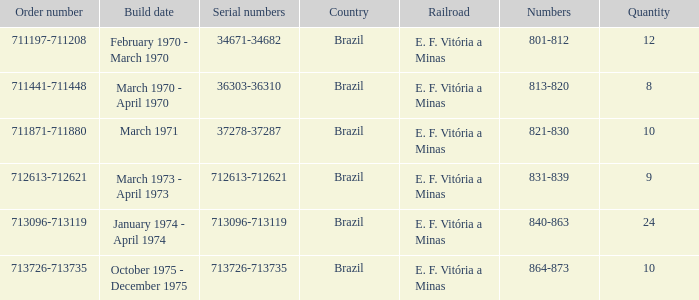The sequence numbers 713096-713119 belong to which nation? Brazil. 